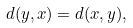Convert formula to latex. <formula><loc_0><loc_0><loc_500><loc_500>d ( y , x ) = d ( x , y ) ,</formula> 